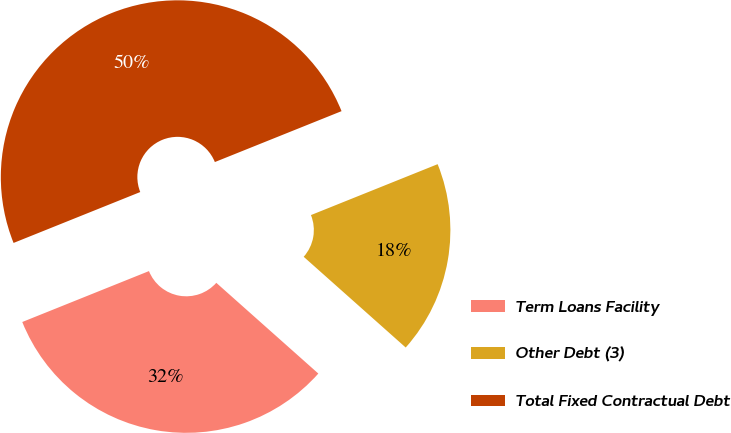<chart> <loc_0><loc_0><loc_500><loc_500><pie_chart><fcel>Term Loans Facility<fcel>Other Debt (3)<fcel>Total Fixed Contractual Debt<nl><fcel>32.35%<fcel>17.65%<fcel>50.0%<nl></chart> 